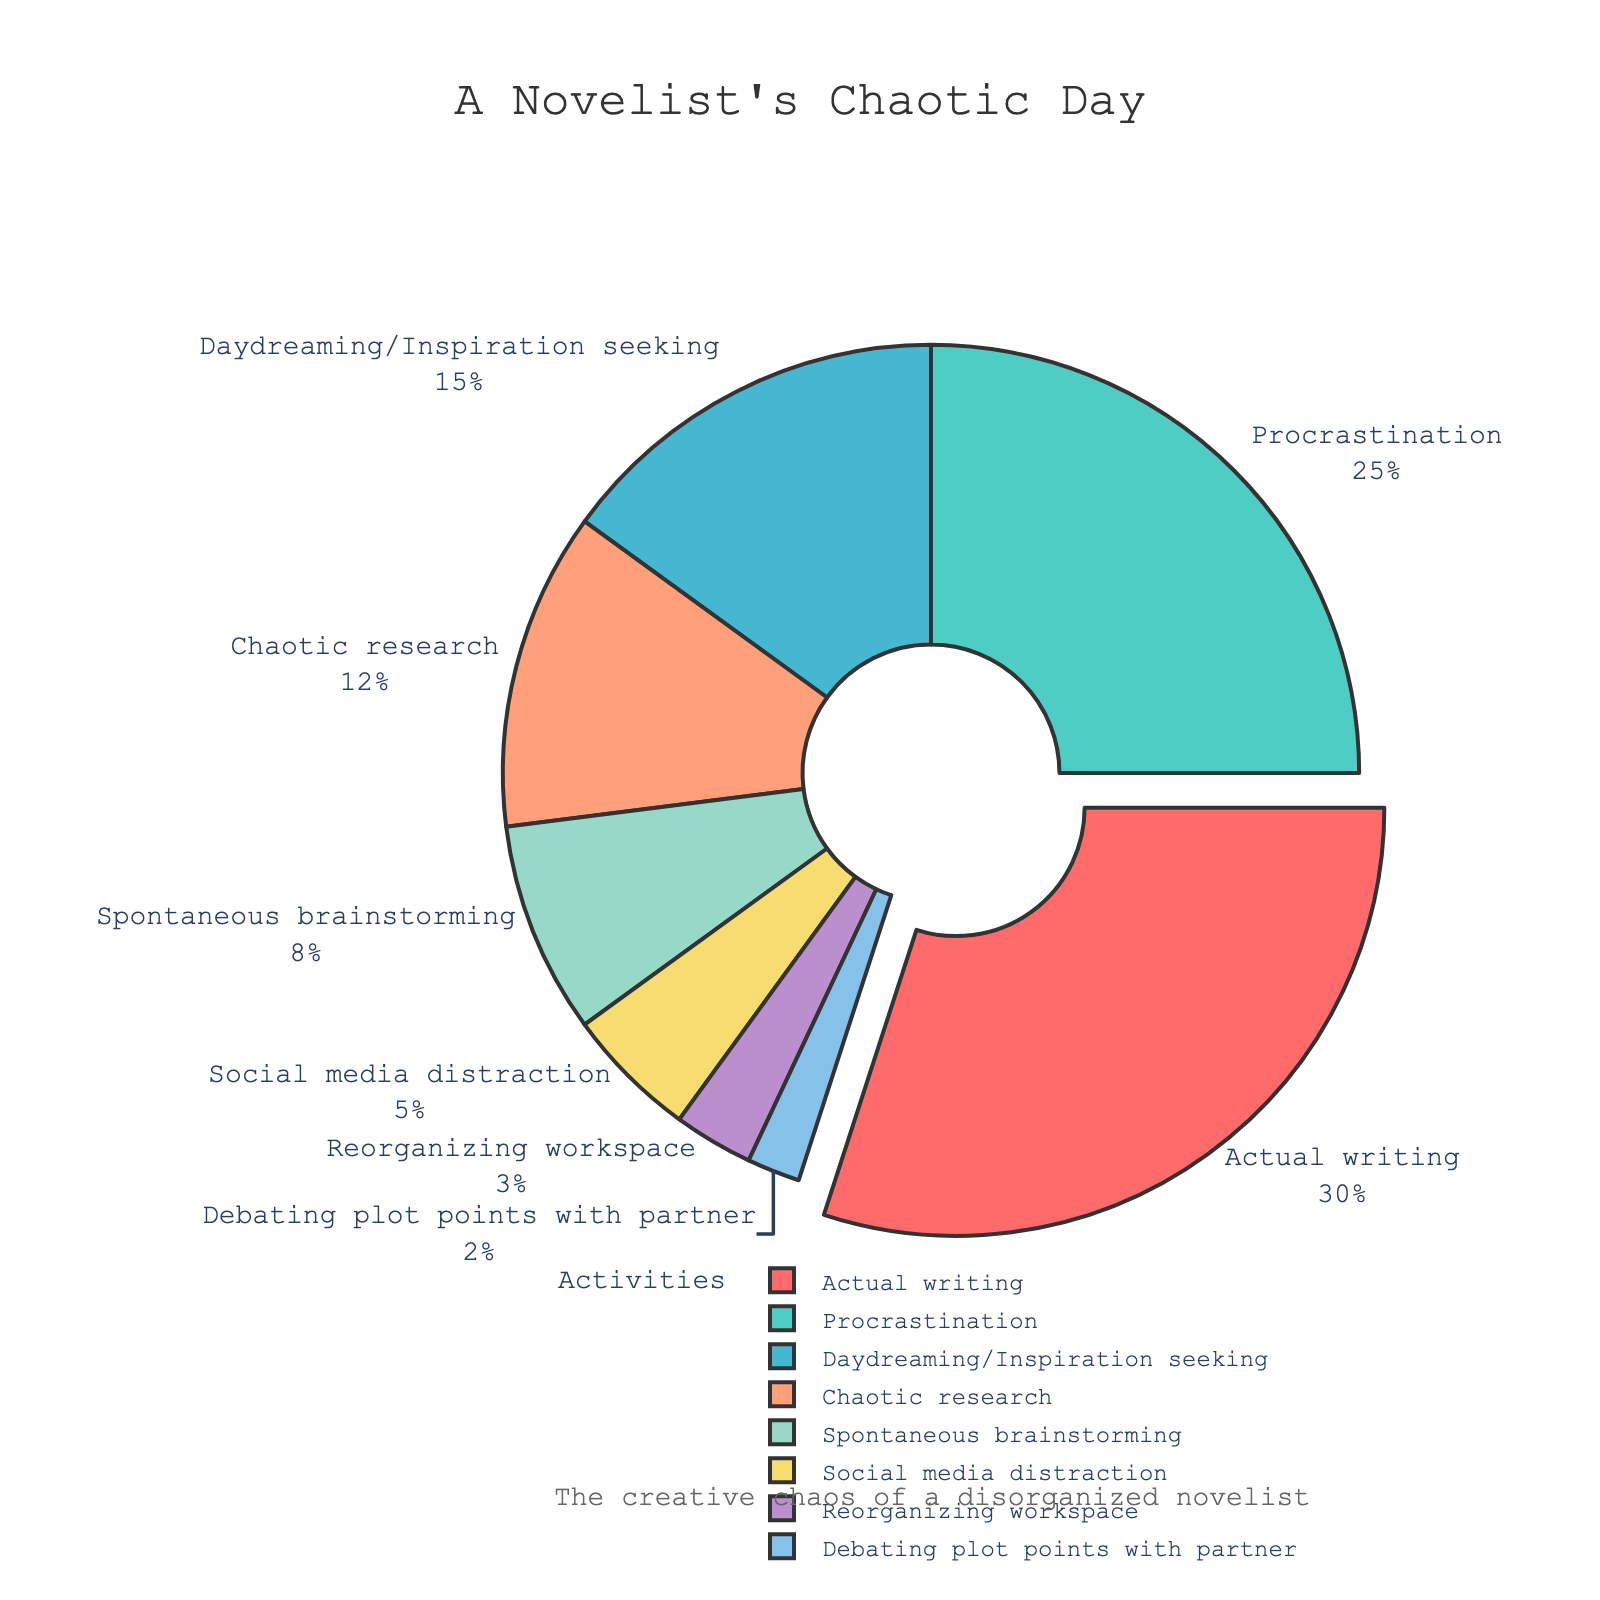What's the largest segment in the chart? The largest segment can be identified by comparing the percentages. The biggest slice is the one marked "Actual writing" with 30%.
Answer: Actual writing Which activity takes up a quarter of the day? A quarter of the day is equivalent to 25%. The segment marked "Procrastination" is exactly 25%.
Answer: Procrastination What is the combined percentage of Chaotic research and Spontaneous brainstorming? To find the combined percentage, add the values of these two activities: Chaotic research (12%) + Spontaneous brainstorming (8%) = 20%.
Answer: 20% Which activities combined occupy less time than Procrastination alone? Procrastination takes 25%. Activities whose percentages sum up to less than 25% are Daydreaming/Inspiration seeking (15%), Social media distraction (5%), Reorganizing workspace (3%), Debating plot points with partner (2%). The sum is 15% + 5% + 3% + 2% = 25%, thus there is no combination of activities that sum up to less than Procrastination.
Answer: None How much more time is spent on Actual writing compared to Debating plot points with partner? Actual writing takes 30% while Debating plot points with partner takes 2%. The difference is 30% - 2% = 28%.
Answer: 28% Which activity has the smallest segment in the pie chart? The smallest segment is identified by the lowest percentage. "Debating plot points with partner" has the smallest slice with 2%.
Answer: Debating plot points with partner What percentage of time is spent on Procrastination and Daydreaming/Inspiration seeking combined? Add the percentages of Procrastination (25%) and Daydreaming/Inspiration seeking (15%): 25% + 15% = 40%.
Answer: 40% Is more time spent on social media distraction or reorganizing workspace? Social media distraction (5%) is greater than reorganizing workspace (3%).
Answer: Social media distraction Which activities together constitute more than half of the day? Analyzing combinations: Actual writing (30%) + Procrastination (25%) = 55%. These two alone already make up more than half the day.
Answer: Actual writing and Procrastination What is the second-largest activity segment? The second-largest segment is the one after the largest (Actual writing at 30%). The next largest is "Procrastination" at 25%.
Answer: Procrastination 